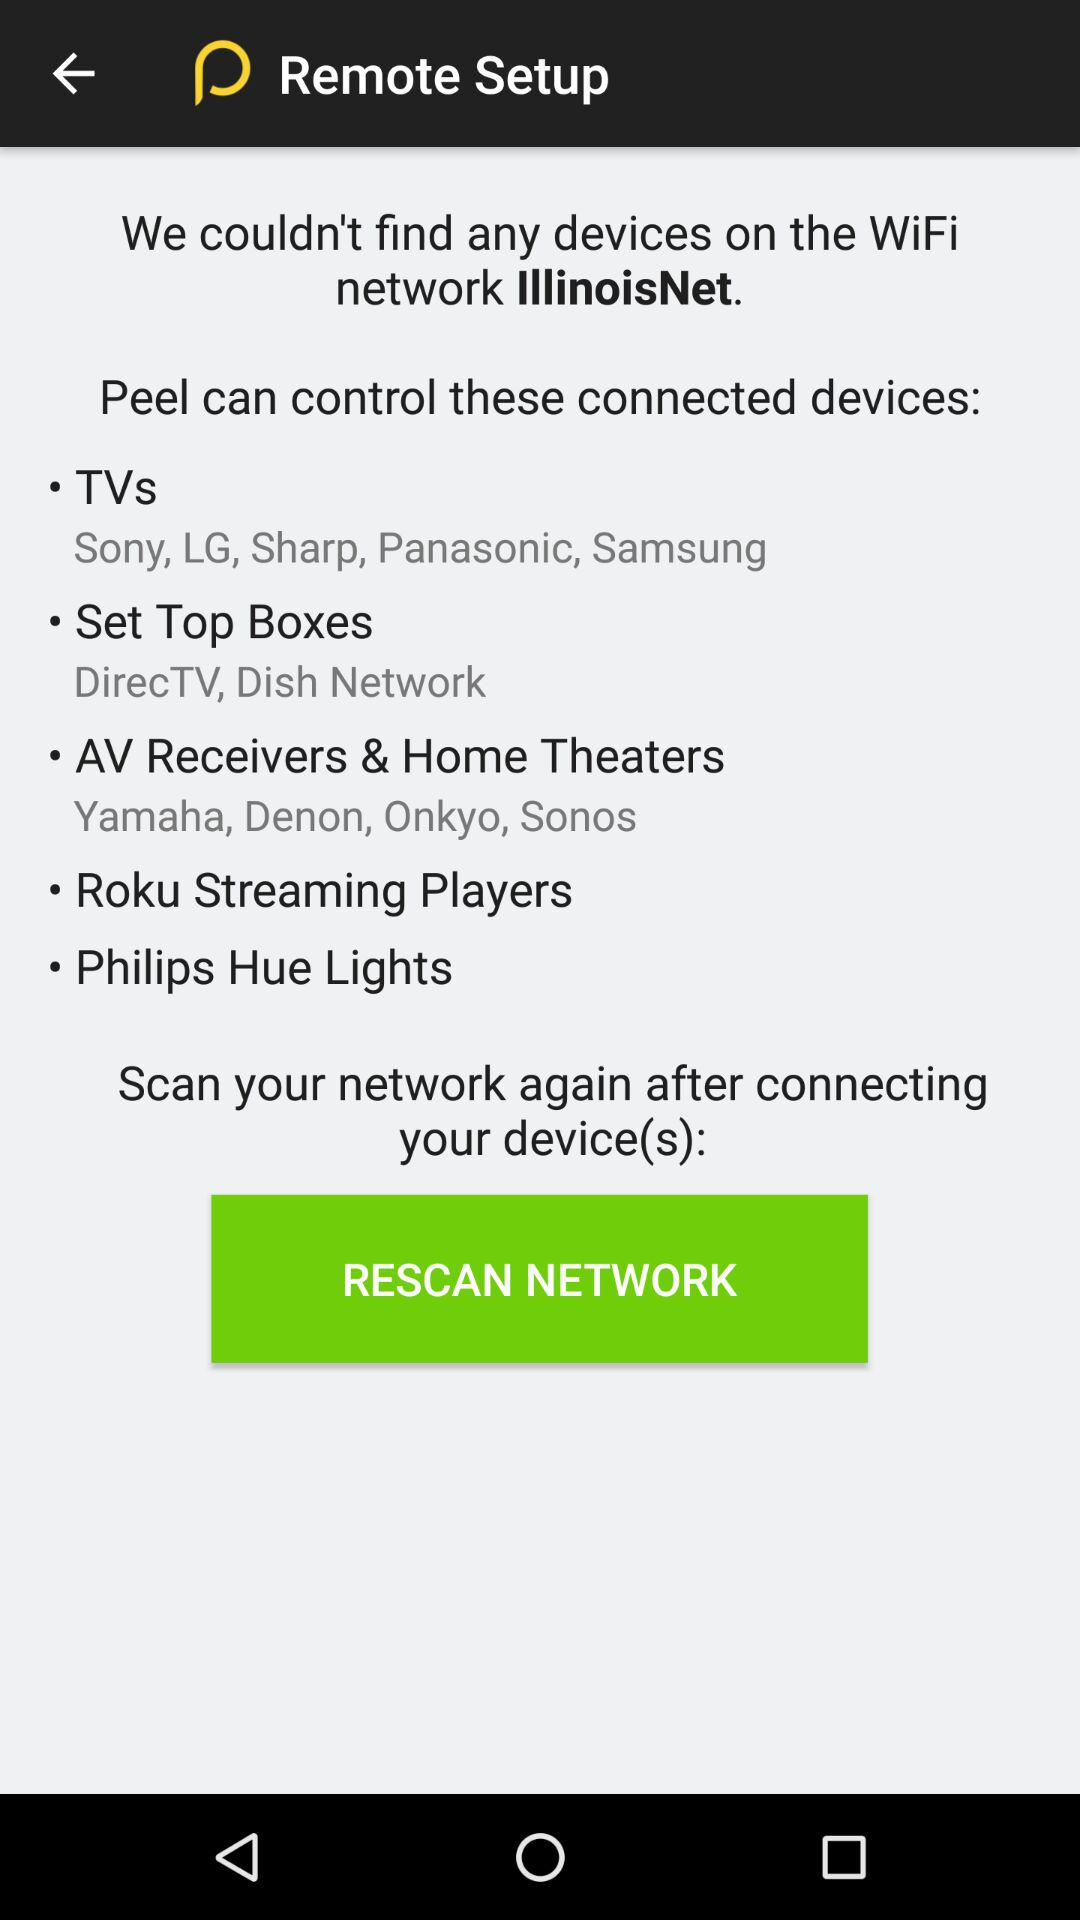Which TV brands can "Peel" control when connected to the same network? TV brands are Sony, LG, Sharp, Panasonic and Samsung. 